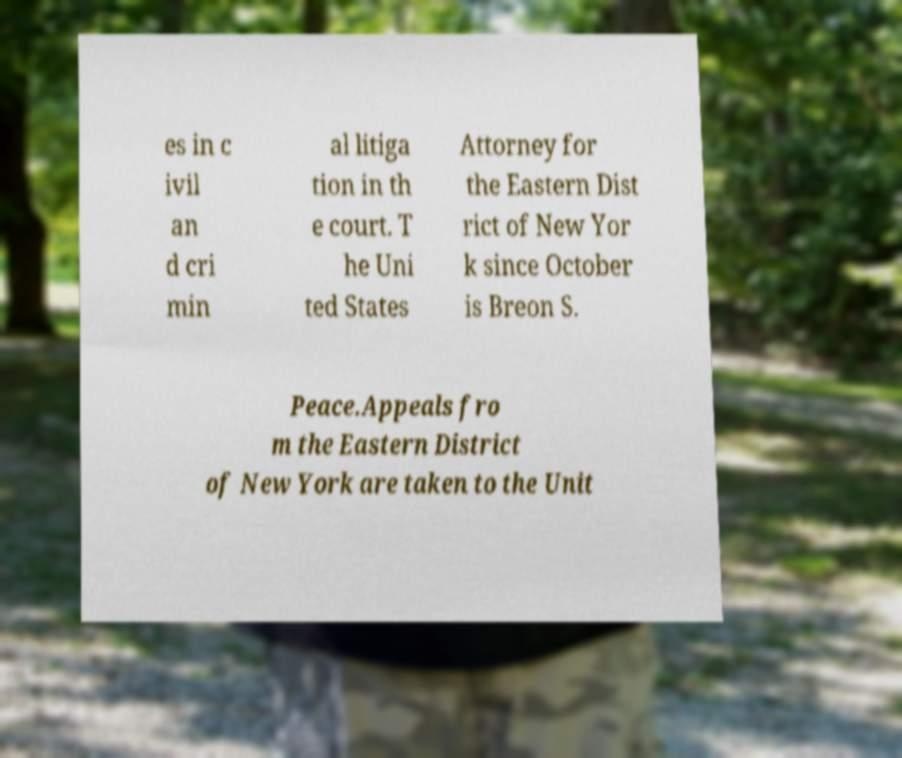There's text embedded in this image that I need extracted. Can you transcribe it verbatim? es in c ivil an d cri min al litiga tion in th e court. T he Uni ted States Attorney for the Eastern Dist rict of New Yor k since October is Breon S. Peace.Appeals fro m the Eastern District of New York are taken to the Unit 